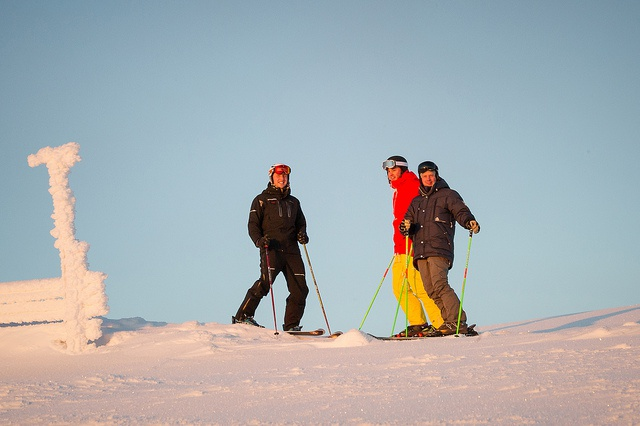Describe the objects in this image and their specific colors. I can see people in gray, black, lightblue, maroon, and tan tones, people in gray, maroon, black, and brown tones, people in gray, orange, red, maroon, and black tones, skis in gray, tan, maroon, darkgray, and black tones, and skis in gray, maroon, black, and olive tones in this image. 